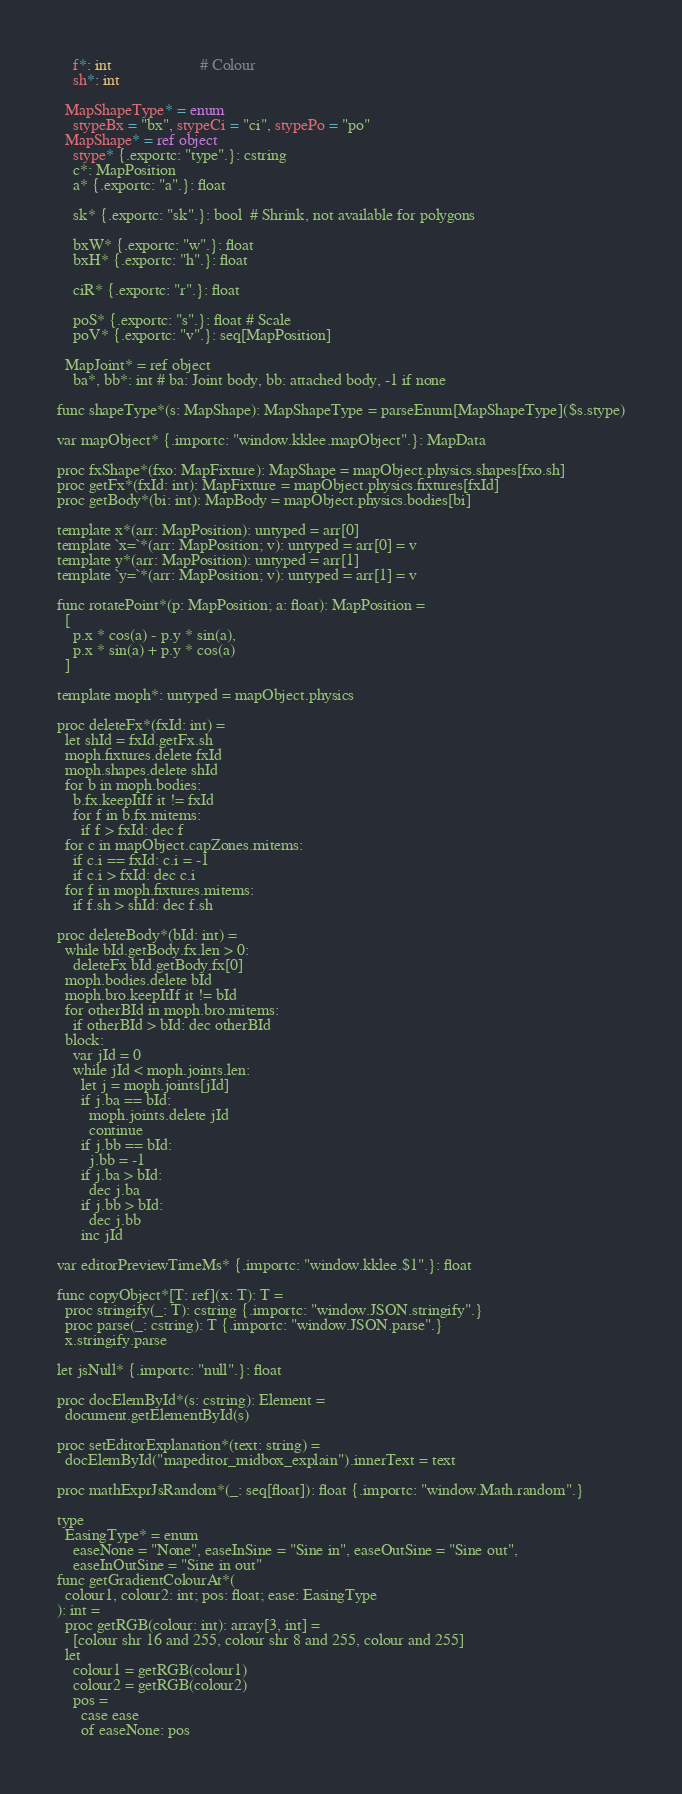Convert code to text. <code><loc_0><loc_0><loc_500><loc_500><_Nim_>    f*: int                      # Colour
    sh*: int

  MapShapeType* = enum
    stypeBx = "bx", stypeCi = "ci", stypePo = "po"
  MapShape* = ref object
    stype* {.exportc: "type".}: cstring
    c*: MapPosition
    a* {.exportc: "a".}: float

    sk* {.exportc: "sk".}: bool  # Shrink, not available for polygons

    bxW* {.exportc: "w".}: float
    bxH* {.exportc: "h".}: float

    ciR* {.exportc: "r".}: float

    poS* {.exportc: "s".}: float # Scale
    poV* {.exportc: "v".}: seq[MapPosition]

  MapJoint* = ref object
    ba*, bb*: int # ba: Joint body, bb: attached body, -1 if none

func shapeType*(s: MapShape): MapShapeType = parseEnum[MapShapeType]($s.stype)

var mapObject* {.importc: "window.kklee.mapObject".}: MapData

proc fxShape*(fxo: MapFixture): MapShape = mapObject.physics.shapes[fxo.sh]
proc getFx*(fxId: int): MapFixture = mapObject.physics.fixtures[fxId]
proc getBody*(bi: int): MapBody = mapObject.physics.bodies[bi]

template x*(arr: MapPosition): untyped = arr[0]
template `x=`*(arr: MapPosition; v): untyped = arr[0] = v
template y*(arr: MapPosition): untyped = arr[1]
template `y=`*(arr: MapPosition; v): untyped = arr[1] = v

func rotatePoint*(p: MapPosition; a: float): MapPosition =
  [
    p.x * cos(a) - p.y * sin(a),
    p.x * sin(a) + p.y * cos(a)
  ]

template moph*: untyped = mapObject.physics

proc deleteFx*(fxId: int) =
  let shId = fxId.getFx.sh
  moph.fixtures.delete fxId
  moph.shapes.delete shId
  for b in moph.bodies:
    b.fx.keepItIf it != fxId
    for f in b.fx.mitems:
      if f > fxId: dec f
  for c in mapObject.capZones.mitems:
    if c.i == fxId: c.i = -1
    if c.i > fxId: dec c.i
  for f in moph.fixtures.mitems:
    if f.sh > shId: dec f.sh

proc deleteBody*(bId: int) =
  while bId.getBody.fx.len > 0:
    deleteFx bId.getBody.fx[0]
  moph.bodies.delete bId
  moph.bro.keepItIf it != bId
  for otherBId in moph.bro.mitems:
    if otherBId > bId: dec otherBId
  block:
    var jId = 0
    while jId < moph.joints.len:
      let j = moph.joints[jId]
      if j.ba == bId:
        moph.joints.delete jId
        continue
      if j.bb == bId:
        j.bb = -1
      if j.ba > bId:
        dec j.ba
      if j.bb > bId:
        dec j.bb
      inc jId

var editorPreviewTimeMs* {.importc: "window.kklee.$1".}: float

func copyObject*[T: ref](x: T): T =
  proc stringify(_: T): cstring {.importc: "window.JSON.stringify".}
  proc parse(_: cstring): T {.importc: "window.JSON.parse".}
  x.stringify.parse

let jsNull* {.importc: "null".}: float

proc docElemById*(s: cstring): Element =
  document.getElementById(s)

proc setEditorExplanation*(text: string) =
  docElemById("mapeditor_midbox_explain").innerText = text

proc mathExprJsRandom*(_: seq[float]): float {.importc: "window.Math.random".}

type
  EasingType* = enum
    easeNone = "None", easeInSine = "Sine in", easeOutSine = "Sine out",
    easeInOutSine = "Sine in out"
func getGradientColourAt*(
  colour1, colour2: int; pos: float; ease: EasingType
): int =
  proc getRGB(colour: int): array[3, int] =
    [colour shr 16 and 255, colour shr 8 and 255, colour and 255]
  let
    colour1 = getRGB(colour1)
    colour2 = getRGB(colour2)
    pos =
      case ease
      of easeNone: pos</code> 